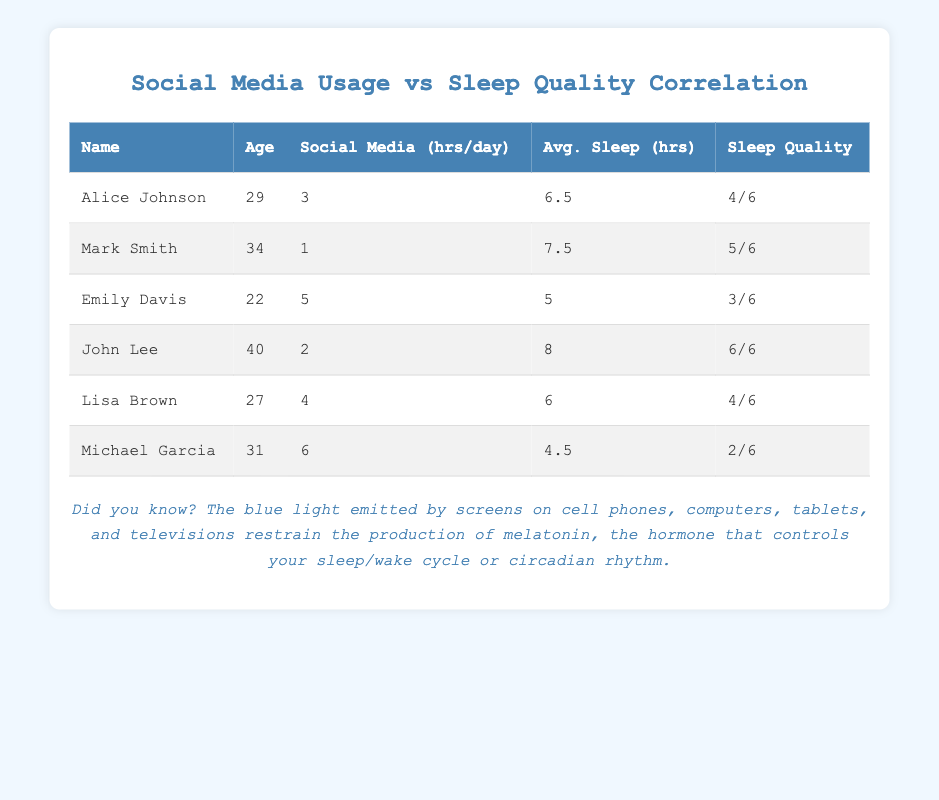What is the maximum number of social media hours per day recorded in the table? Looking at the column for social media hours per day, the values are 3, 1, 5, 2, 4, and 6. The maximum value in this column is 6 hours, which belongs to Michael Garcia.
Answer: 6 What is the average sleep quality rating of people who use social media for 4 hours or more? The people who use social media for 4 hours or more are Emily Davis (3), Lisa Brown (4), and Michael Garcia (2). Adding these ratings gives: 3 + 4 + 2 = 9. There are three data points, so the average sleep quality rating is 9/3 = 3.
Answer: 3 Is there anyone in the table who uses social media for 2 hours a day? From the social media hours per day column, John Lee is the only individual who uses social media for exactly 2 hours a day.
Answer: Yes What are the average sleep hours of individuals who rate their sleep quality as 5? Only Mark Smith rates his sleep quality as 5, and he has an average of 7.5 hours of sleep. Therefore, the average sleep hours for those with a rating of 5 is simply 7.5 hours.
Answer: 7.5 Which individual sleeps the least on average, and what is their sleep quality rating? The individual who sleeps the least is Michael Garcia, with an average sleep of 4.5 hours. His sleep quality rating is 2. This is derived from examining the average sleep hours column to find the minimum.
Answer: Michael Garcia, 2 What is the combined average sleep quality for users who spend less than 3 hours on social media daily? The individuals who spend less than 3 hours on social media are Mark Smith (5) and John Lee (6). Adding the ratings gives: 5 + 6 = 11. There are two data points, so the average is 11/2 = 5.5.
Answer: 5.5 How many individuals have a sleep quality rating of 4 or higher? Looking through the sleep quality ratings, we find Alice Johnson (4), John Lee (6), and Lisa Brown (4), which totals three individuals.
Answer: 3 What is the difference between the maximum and minimum average sleep hours recorded? The maximum average sleep hours is 8 from John Lee and the minimum is 4.5 from Michael Garcia. The difference is calculated as 8 - 4.5 = 3.5.
Answer: 3.5 